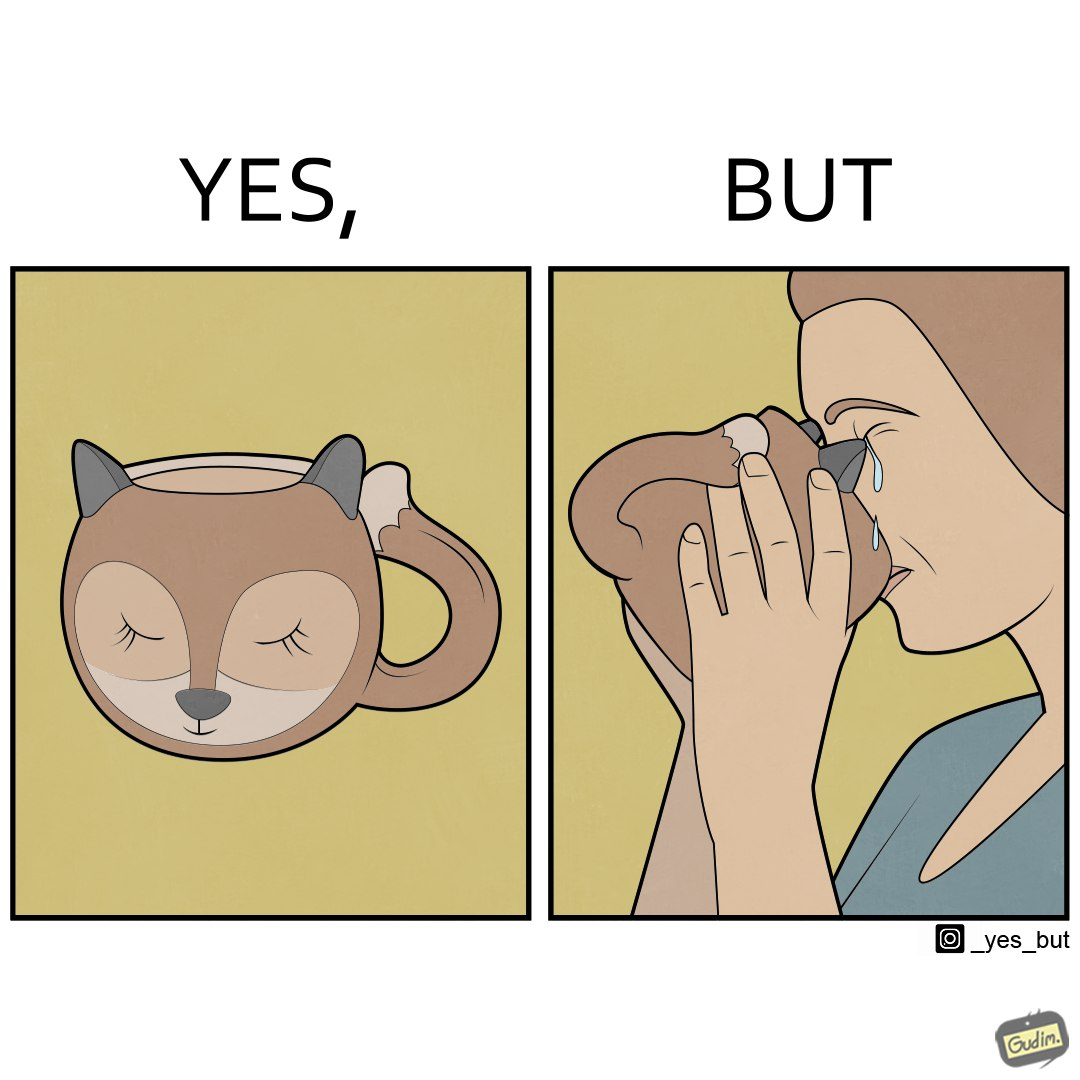Would you classify this image as satirical? Yes, this image is satirical. 